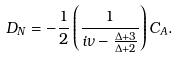<formula> <loc_0><loc_0><loc_500><loc_500>D _ { N } = - \frac { 1 } { 2 } \left ( \frac { 1 } { i \nu - \frac { \Delta + 3 } { \Delta + 2 } } \right ) C _ { A } .</formula> 